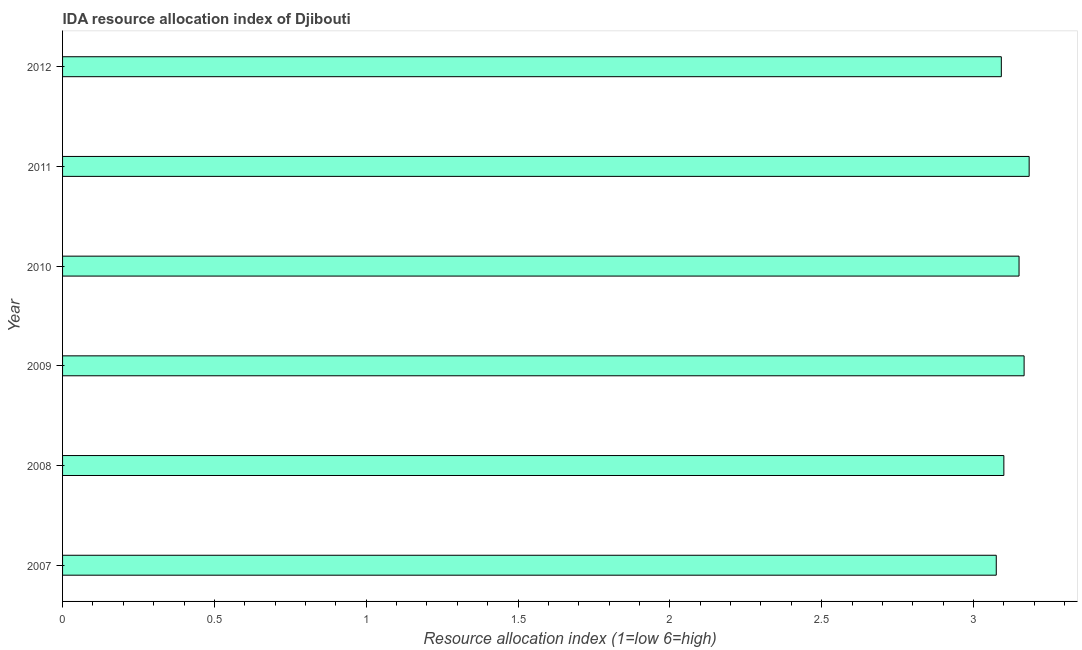Does the graph contain any zero values?
Make the answer very short. No. Does the graph contain grids?
Provide a short and direct response. No. What is the title of the graph?
Provide a short and direct response. IDA resource allocation index of Djibouti. What is the label or title of the X-axis?
Your answer should be very brief. Resource allocation index (1=low 6=high). What is the label or title of the Y-axis?
Your response must be concise. Year. What is the ida resource allocation index in 2010?
Keep it short and to the point. 3.15. Across all years, what is the maximum ida resource allocation index?
Offer a terse response. 3.18. Across all years, what is the minimum ida resource allocation index?
Your response must be concise. 3.08. In which year was the ida resource allocation index minimum?
Ensure brevity in your answer.  2007. What is the sum of the ida resource allocation index?
Offer a terse response. 18.77. What is the average ida resource allocation index per year?
Make the answer very short. 3.13. What is the median ida resource allocation index?
Make the answer very short. 3.12. In how many years, is the ida resource allocation index greater than 2.2 ?
Keep it short and to the point. 6. What is the difference between the highest and the second highest ida resource allocation index?
Provide a succinct answer. 0.02. What is the difference between the highest and the lowest ida resource allocation index?
Give a very brief answer. 0.11. In how many years, is the ida resource allocation index greater than the average ida resource allocation index taken over all years?
Provide a short and direct response. 3. Are all the bars in the graph horizontal?
Your answer should be very brief. Yes. How many years are there in the graph?
Provide a short and direct response. 6. What is the difference between two consecutive major ticks on the X-axis?
Offer a very short reply. 0.5. What is the Resource allocation index (1=low 6=high) of 2007?
Give a very brief answer. 3.08. What is the Resource allocation index (1=low 6=high) of 2008?
Your answer should be compact. 3.1. What is the Resource allocation index (1=low 6=high) of 2009?
Offer a terse response. 3.17. What is the Resource allocation index (1=low 6=high) of 2010?
Keep it short and to the point. 3.15. What is the Resource allocation index (1=low 6=high) in 2011?
Your response must be concise. 3.18. What is the Resource allocation index (1=low 6=high) in 2012?
Keep it short and to the point. 3.09. What is the difference between the Resource allocation index (1=low 6=high) in 2007 and 2008?
Offer a terse response. -0.03. What is the difference between the Resource allocation index (1=low 6=high) in 2007 and 2009?
Offer a very short reply. -0.09. What is the difference between the Resource allocation index (1=low 6=high) in 2007 and 2010?
Your answer should be compact. -0.07. What is the difference between the Resource allocation index (1=low 6=high) in 2007 and 2011?
Provide a succinct answer. -0.11. What is the difference between the Resource allocation index (1=low 6=high) in 2007 and 2012?
Provide a short and direct response. -0.02. What is the difference between the Resource allocation index (1=low 6=high) in 2008 and 2009?
Provide a short and direct response. -0.07. What is the difference between the Resource allocation index (1=low 6=high) in 2008 and 2011?
Your response must be concise. -0.08. What is the difference between the Resource allocation index (1=low 6=high) in 2008 and 2012?
Make the answer very short. 0.01. What is the difference between the Resource allocation index (1=low 6=high) in 2009 and 2010?
Provide a short and direct response. 0.02. What is the difference between the Resource allocation index (1=low 6=high) in 2009 and 2011?
Your response must be concise. -0.02. What is the difference between the Resource allocation index (1=low 6=high) in 2009 and 2012?
Offer a very short reply. 0.07. What is the difference between the Resource allocation index (1=low 6=high) in 2010 and 2011?
Make the answer very short. -0.03. What is the difference between the Resource allocation index (1=low 6=high) in 2010 and 2012?
Keep it short and to the point. 0.06. What is the difference between the Resource allocation index (1=low 6=high) in 2011 and 2012?
Offer a terse response. 0.09. What is the ratio of the Resource allocation index (1=low 6=high) in 2007 to that in 2008?
Your answer should be very brief. 0.99. What is the ratio of the Resource allocation index (1=low 6=high) in 2007 to that in 2009?
Give a very brief answer. 0.97. What is the ratio of the Resource allocation index (1=low 6=high) in 2007 to that in 2011?
Your answer should be very brief. 0.97. What is the ratio of the Resource allocation index (1=low 6=high) in 2007 to that in 2012?
Give a very brief answer. 0.99. What is the ratio of the Resource allocation index (1=low 6=high) in 2008 to that in 2009?
Your response must be concise. 0.98. What is the ratio of the Resource allocation index (1=low 6=high) in 2008 to that in 2010?
Ensure brevity in your answer.  0.98. What is the ratio of the Resource allocation index (1=low 6=high) in 2008 to that in 2011?
Give a very brief answer. 0.97. What is the ratio of the Resource allocation index (1=low 6=high) in 2008 to that in 2012?
Make the answer very short. 1. What is the ratio of the Resource allocation index (1=low 6=high) in 2010 to that in 2011?
Your answer should be compact. 0.99. 